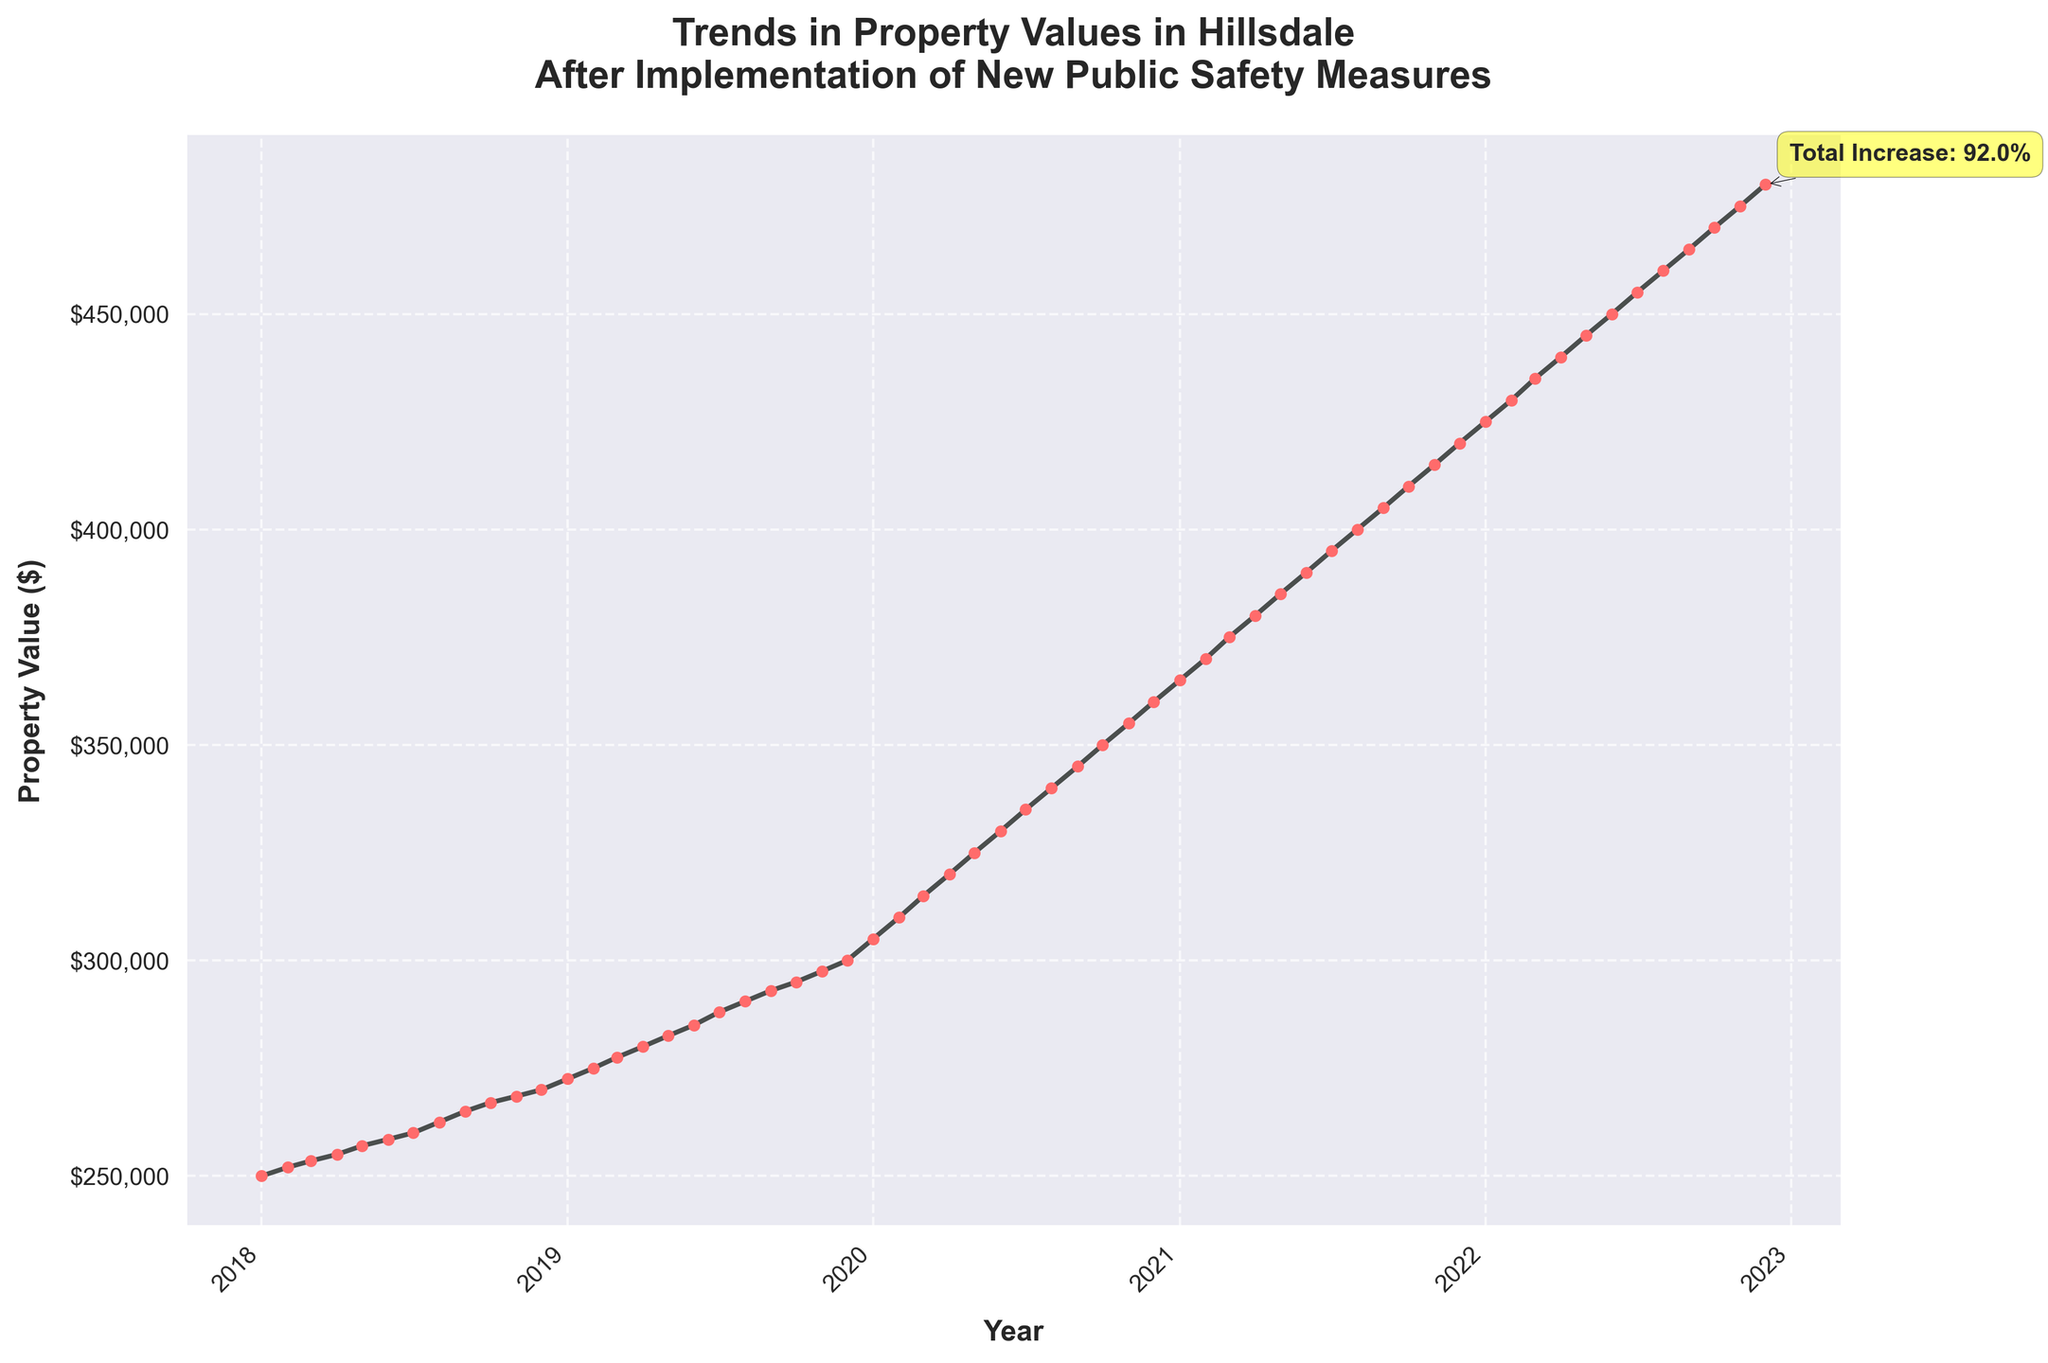When did property values in Hillsdale begin to rise consistently? Property values began to rise consistently from January 2018, as indicated by the steady upward trend starting at that time.
Answer: January 2018 What was the property value in July 2018? The property value in July 2018 can be noted directly from the plot point for that month, which is approximately $260,000.
Answer: $260,000 How much did property values increase by the end of December 2022? By December 2022, property values increased from $250,000 to $480,000. The increase can be calculated as $480,000 - $250,000 = $230,000.
Answer: $230,000 Which year saw the sharpest increase in property values? The sharpest increase can be estimated by examining the slope of the lines; 2021 shows the most significant rise from approximately $365,000 to $420,000, an increase of $55,000 in a year.
Answer: 2021 What is the total percentage increase in property values from January 2018 to December 2022? The percentage increase is calculated as \(\frac{{480,000 - 250,000}}{250,000} \times 100 = 92\%\), and this percentage is also annotated directly on the plot.
Answer: 92% How much did the property value increase between January 2020 and January 2021? Property values increased from $305,000 in January 2020 to $365,000 in January 2021. The increase is $365,000 - $305,000 = $60,000.
Answer: $60,000 What is the trend in property values after the implementation of new public safety measures? The trend shows a consistent increase in property values after the implementation, as depicted by the steady upward trajectory from the start to the end of the plotted period.
Answer: Consistent increase In which month of 2022 did property values reach $450,000? Property values reach $450,000 in June 2022, as stated directly by the data point for that month.
Answer: June 2022 Which year experienced the least increase in property values? The year with the least increase can be determined by checking for the smallest slope between the start and end of each year. 2018 shows the smallest increase from $250,000 to around $270,000, an increase of only $20,000.
Answer: 2018 